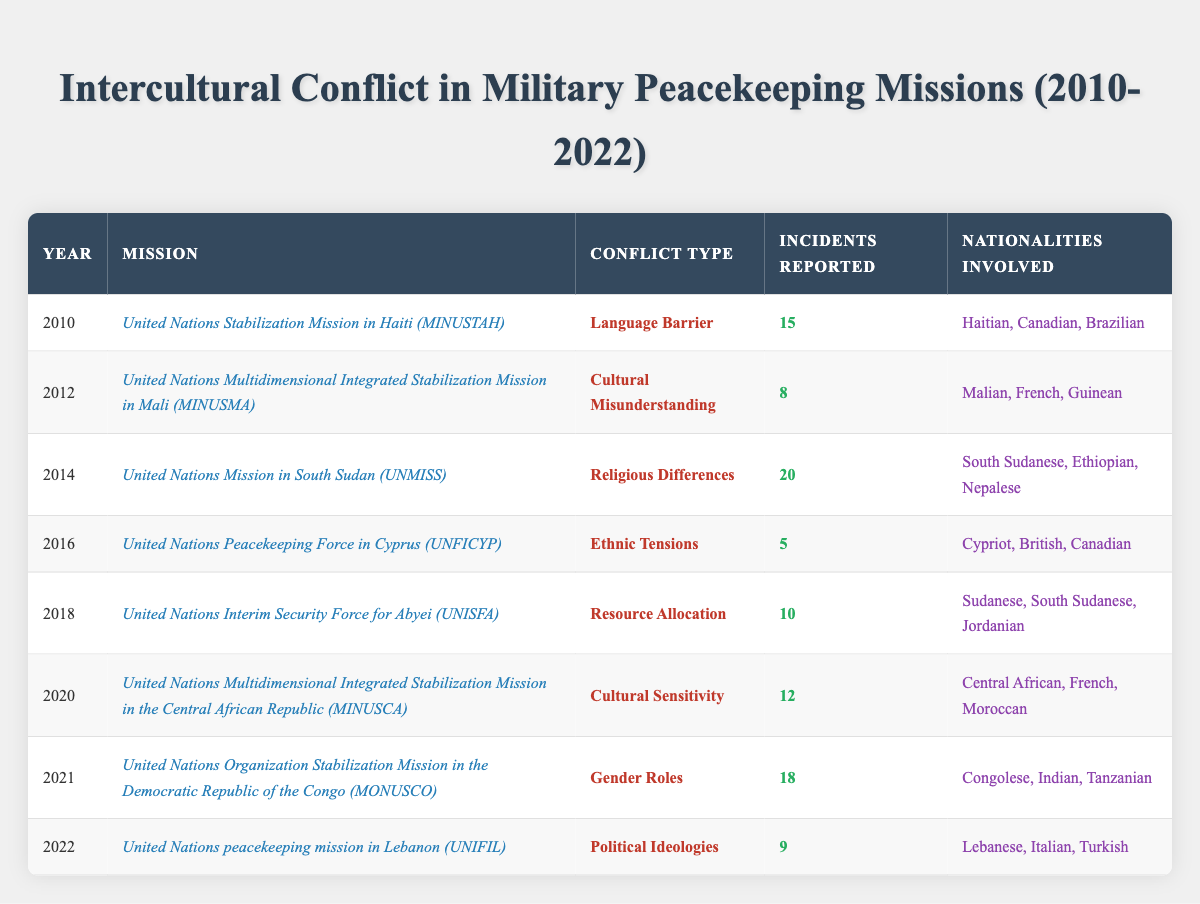What types of conflict were reported during the United Nations Stabilization Mission in Haiti (MINUSTAH) in 2010? The table lists the conflicts reported during each mission. For the 2010 mission, the conflict type is "Language Barrier."
Answer: Language Barrier How many incidents of intercultural conflict were reported in the United Nations Mission in South Sudan (UNMISS) in 2014? Referring to the table, it states that 20 incidents were reported during the UNMISS mission in 2014.
Answer: 20 In which year did the highest number of incidents occur and what was the type of conflict? The 2014 UNMISS records the highest incidents at 20, with the conflict type being "Religious Differences."
Answer: 2014, Religious Differences What was the total number of incidents reported in peacekeeping missions from 2010 to 2022? By summing the incidents reported for each year: 15 + 8 + 20 + 5 + 10 + 12 + 18 + 9 = 97 incidents in total across all years.
Answer: 97 Was there an intercultural conflict related to Gender Roles reported in any peacekeeping missions? Yes, the data indicates that a conflict involving "Gender Roles" was reported in the 2021 MONUSCO mission.
Answer: Yes How many different nationalities were involved in the intercultural conflicts reported in 2020? For the year 2020, there were three nationalities involved according to the data: Central African, French, and Moroccan.
Answer: 3 Which conflict type occurred in 2012, and did it have more or fewer incidents than the 2016 Ethnic Tensions case? The 2012 conflict type was "Cultural Misunderstanding" with 8 incidents. Compared to the 5 incidents of Ethnic Tensions in 2016, this was more.
Answer: More What is the average number of incidents reported across all missions mentioned in the table? The total number of incidents is 97 from 8 missions. Dividing 97 by 8 gives an average of 12.125, which rounds to 12.12 incidents per mission.
Answer: 12.12 In how many missions did the conflict type involve Resource Allocation? The table indicates that "Resource Allocation" was reported only in the 2018 UNISFA mission.
Answer: 1 